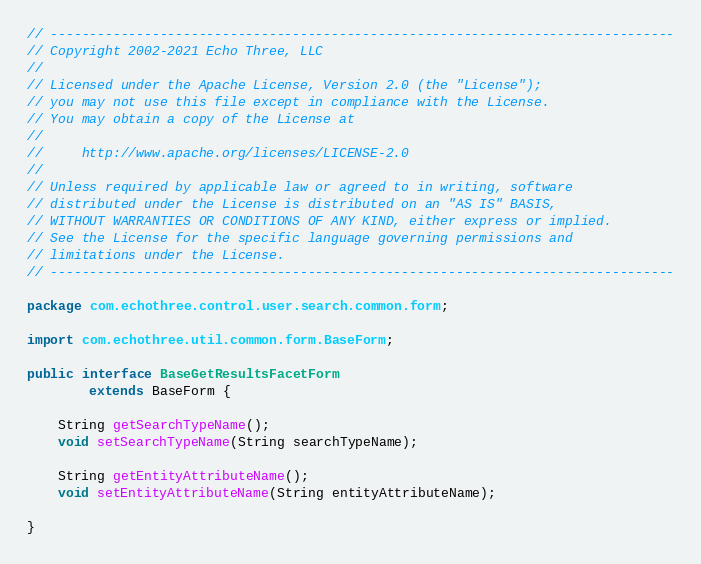Convert code to text. <code><loc_0><loc_0><loc_500><loc_500><_Java_>// --------------------------------------------------------------------------------
// Copyright 2002-2021 Echo Three, LLC
//
// Licensed under the Apache License, Version 2.0 (the "License");
// you may not use this file except in compliance with the License.
// You may obtain a copy of the License at
//
//     http://www.apache.org/licenses/LICENSE-2.0
//
// Unless required by applicable law or agreed to in writing, software
// distributed under the License is distributed on an "AS IS" BASIS,
// WITHOUT WARRANTIES OR CONDITIONS OF ANY KIND, either express or implied.
// See the License for the specific language governing permissions and
// limitations under the License.
// --------------------------------------------------------------------------------

package com.echothree.control.user.search.common.form;

import com.echothree.util.common.form.BaseForm;

public interface BaseGetResultsFacetForm
        extends BaseForm {
    
    String getSearchTypeName();
    void setSearchTypeName(String searchTypeName);
    
    String getEntityAttributeName();
    void setEntityAttributeName(String entityAttributeName);
    
}
</code> 